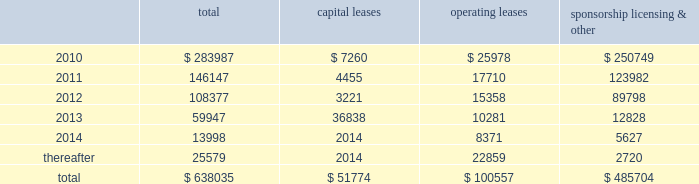Mastercard incorporated notes to consolidated financial statements 2014 ( continued ) ( in thousands , except percent and per share data ) equity awards was $ 30333 , $ 20726 and $ 19828 for the years ended december 31 , 2009 , 2008 and 2007 , respectively .
The income tax benefit related to options exercised during 2009 was $ 7545 .
The additional paid-in capital balance attributed to the equity awards was $ 197350 , $ 135538 and $ 114637 as of december 31 , 2009 , 2008 and 2007 , respectively .
On july 18 , 2006 , the company 2019s stockholders approved the mastercard incorporated 2006 non-employee director equity compensation plan ( the 201cdirector plan 201d ) .
The director plan provides for awards of deferred stock units ( 201cdsus 201d ) to each director of the company who is not a current employee of the company .
There are 100 shares of class a common stock reserved for dsu awards under the director plan .
During the years ended december 31 , 2009 , 2008 and 2007 , the company granted 7 dsus , 4 dsus and 8 dsus , respectively .
The fair value of the dsus was based on the closing stock price on the new york stock exchange of the company 2019s class a common stock on the date of grant .
The weighted average grant-date fair value of dsus granted during the years ended december 31 , 2009 , 2008 and 2007 was $ 168.18 , $ 284.92 and $ 139.27 , respectively .
The dsus vested immediately upon grant and will be settled in shares of the company 2019s class a common stock on the fourth anniversary of the date of grant .
Accordingly , the company recorded general and administrative expense of $ 1151 , $ 1209 and $ 1051 for the dsus for the years ended december 31 , 2009 , 2008 and 2007 , respectively .
The total income tax benefit recognized in the income statement for dsus was $ 410 , $ 371 and $ 413 for the years ended december 31 , 2009 , 2008 and 2007 , respectively .
Note 18 .
Commitments at december 31 , 2009 , the company had the following future minimum payments due under non-cancelable agreements : capital leases operating leases sponsorship , licensing & .
Included in the table above are capital leases with imputed interest expense of $ 7929 and a net present value of minimum lease payments of $ 43845 .
In addition , at december 31 , 2009 , $ 63616 of the future minimum payments in the table above for leases , sponsorship , licensing and other agreements was accrued .
Consolidated rental expense for the company 2019s office space , which is recognized on a straight line basis over the life of the lease , was approximately $ 39586 , $ 42905 and $ 35614 for the years ended december 31 , 2009 , 2008 and 2007 , respectively .
Consolidated lease expense for automobiles , computer equipment and office equipment was $ 9137 , $ 7694 and $ 7679 for the years ended december 31 , 2009 , 2008 and 2007 , respectively .
In january 2003 , mastercard purchased a building in kansas city , missouri for approximately $ 23572 .
The building is a co-processing data center which replaced a back-up data center in lake success , new york .
During 2003 , mastercard entered into agreements with the city of kansas city for ( i ) the sale-leaseback of the building and related equipment which totaled $ 36382 and ( ii ) the purchase of municipal bonds for the same amount .
In 2010 what was the percent of the operating leases future minimum payments due under non-cancelable agreements to the total $ 7260 $? 
Rationale: in 2010 the operating leases were 9.15% of the total future minimum payments due under non-cancelable agreements
Computations: (25978 / 283987)
Answer: 0.09148. 